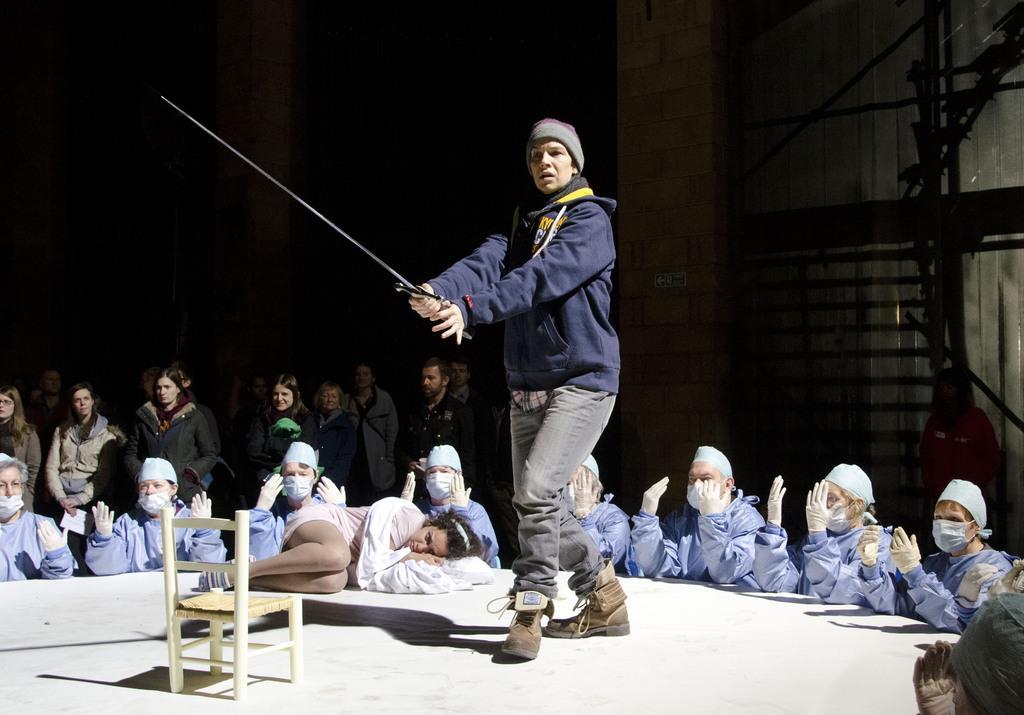Can you describe this image briefly? In the foreground of the picture there is a stage, on the stage there is a chair, a woman holding a sword and a woman lying. In the center of the picture there are women wearing mask and gloves. In the background there are people standing. At the top it is dark. On the right there is staircase and a woman standing. 